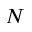<formula> <loc_0><loc_0><loc_500><loc_500>N</formula> 